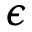<formula> <loc_0><loc_0><loc_500><loc_500>\epsilon</formula> 